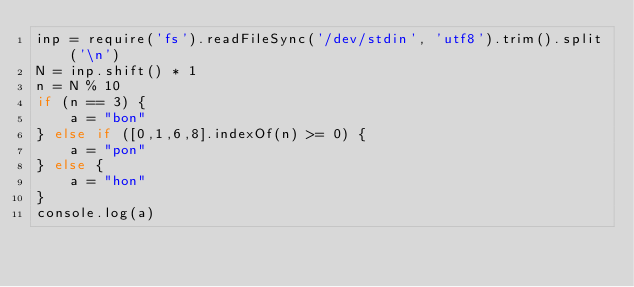Convert code to text. <code><loc_0><loc_0><loc_500><loc_500><_JavaScript_>inp = require('fs').readFileSync('/dev/stdin', 'utf8').trim().split('\n')
N = inp.shift() * 1
n = N % 10
if (n == 3) {
    a = "bon"
} else if ([0,1,6,8].indexOf(n) >= 0) {
    a = "pon"
} else {
    a = "hon"
}
console.log(a)</code> 